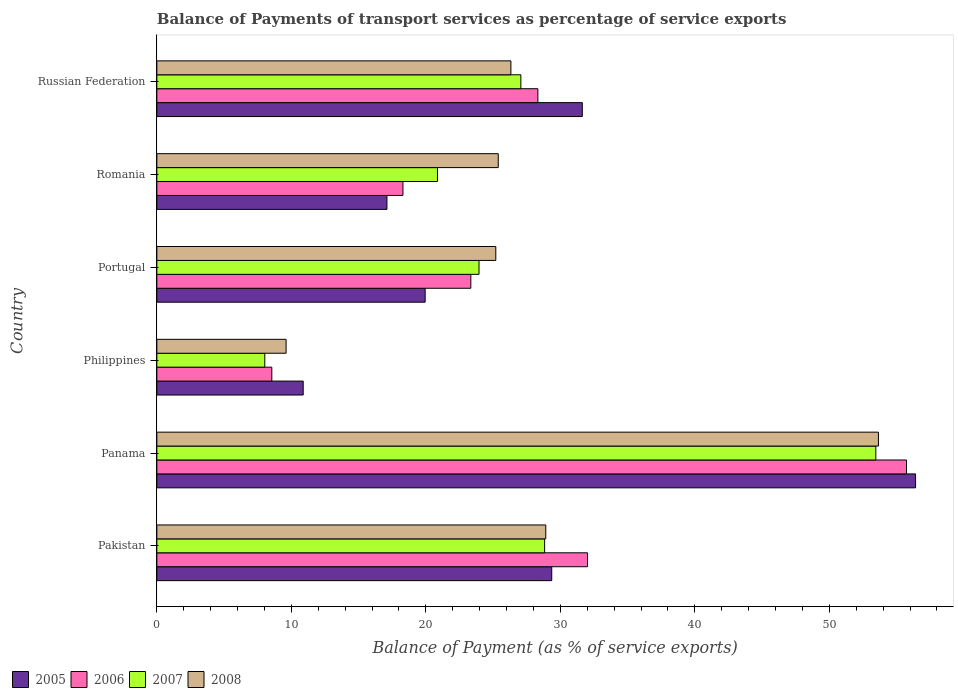How many different coloured bars are there?
Ensure brevity in your answer.  4. How many groups of bars are there?
Your answer should be very brief. 6. Are the number of bars per tick equal to the number of legend labels?
Provide a succinct answer. Yes. How many bars are there on the 4th tick from the bottom?
Your answer should be very brief. 4. What is the label of the 6th group of bars from the top?
Offer a terse response. Pakistan. What is the balance of payments of transport services in 2007 in Panama?
Your response must be concise. 53.45. Across all countries, what is the maximum balance of payments of transport services in 2007?
Give a very brief answer. 53.45. Across all countries, what is the minimum balance of payments of transport services in 2006?
Keep it short and to the point. 8.55. In which country was the balance of payments of transport services in 2008 maximum?
Ensure brevity in your answer.  Panama. In which country was the balance of payments of transport services in 2008 minimum?
Your answer should be very brief. Philippines. What is the total balance of payments of transport services in 2008 in the graph?
Offer a very short reply. 169.08. What is the difference between the balance of payments of transport services in 2008 in Philippines and that in Portugal?
Your answer should be very brief. -15.59. What is the difference between the balance of payments of transport services in 2006 in Russian Federation and the balance of payments of transport services in 2005 in Pakistan?
Give a very brief answer. -1.03. What is the average balance of payments of transport services in 2007 per country?
Offer a terse response. 27.03. What is the difference between the balance of payments of transport services in 2007 and balance of payments of transport services in 2008 in Russian Federation?
Provide a succinct answer. 0.74. In how many countries, is the balance of payments of transport services in 2006 greater than 30 %?
Make the answer very short. 2. What is the ratio of the balance of payments of transport services in 2008 in Panama to that in Philippines?
Ensure brevity in your answer.  5.58. Is the balance of payments of transport services in 2007 in Romania less than that in Russian Federation?
Your answer should be compact. Yes. Is the difference between the balance of payments of transport services in 2007 in Philippines and Portugal greater than the difference between the balance of payments of transport services in 2008 in Philippines and Portugal?
Offer a very short reply. No. What is the difference between the highest and the second highest balance of payments of transport services in 2007?
Provide a short and direct response. 24.62. What is the difference between the highest and the lowest balance of payments of transport services in 2005?
Your answer should be very brief. 45.53. What does the 1st bar from the bottom in Philippines represents?
Your answer should be compact. 2005. How many bars are there?
Your answer should be compact. 24. How many countries are there in the graph?
Keep it short and to the point. 6. Are the values on the major ticks of X-axis written in scientific E-notation?
Offer a very short reply. No. Does the graph contain any zero values?
Offer a very short reply. No. Does the graph contain grids?
Provide a succinct answer. No. Where does the legend appear in the graph?
Ensure brevity in your answer.  Bottom left. How many legend labels are there?
Provide a short and direct response. 4. What is the title of the graph?
Make the answer very short. Balance of Payments of transport services as percentage of service exports. What is the label or title of the X-axis?
Your answer should be very brief. Balance of Payment (as % of service exports). What is the Balance of Payment (as % of service exports) in 2005 in Pakistan?
Your answer should be compact. 29.36. What is the Balance of Payment (as % of service exports) of 2006 in Pakistan?
Make the answer very short. 32.02. What is the Balance of Payment (as % of service exports) of 2007 in Pakistan?
Your response must be concise. 28.83. What is the Balance of Payment (as % of service exports) in 2008 in Pakistan?
Offer a terse response. 28.91. What is the Balance of Payment (as % of service exports) in 2005 in Panama?
Your response must be concise. 56.41. What is the Balance of Payment (as % of service exports) in 2006 in Panama?
Your answer should be very brief. 55.73. What is the Balance of Payment (as % of service exports) in 2007 in Panama?
Your response must be concise. 53.45. What is the Balance of Payment (as % of service exports) of 2008 in Panama?
Your answer should be very brief. 53.65. What is the Balance of Payment (as % of service exports) of 2005 in Philippines?
Offer a very short reply. 10.88. What is the Balance of Payment (as % of service exports) of 2006 in Philippines?
Ensure brevity in your answer.  8.55. What is the Balance of Payment (as % of service exports) in 2007 in Philippines?
Ensure brevity in your answer.  8.02. What is the Balance of Payment (as % of service exports) of 2008 in Philippines?
Your response must be concise. 9.61. What is the Balance of Payment (as % of service exports) in 2005 in Portugal?
Keep it short and to the point. 19.95. What is the Balance of Payment (as % of service exports) of 2006 in Portugal?
Provide a succinct answer. 23.34. What is the Balance of Payment (as % of service exports) of 2007 in Portugal?
Provide a short and direct response. 23.95. What is the Balance of Payment (as % of service exports) of 2008 in Portugal?
Your answer should be very brief. 25.2. What is the Balance of Payment (as % of service exports) in 2005 in Romania?
Provide a short and direct response. 17.11. What is the Balance of Payment (as % of service exports) in 2006 in Romania?
Keep it short and to the point. 18.3. What is the Balance of Payment (as % of service exports) in 2007 in Romania?
Provide a succinct answer. 20.86. What is the Balance of Payment (as % of service exports) in 2008 in Romania?
Keep it short and to the point. 25.38. What is the Balance of Payment (as % of service exports) of 2005 in Russian Federation?
Your answer should be compact. 31.63. What is the Balance of Payment (as % of service exports) in 2006 in Russian Federation?
Your answer should be compact. 28.33. What is the Balance of Payment (as % of service exports) in 2007 in Russian Federation?
Provide a succinct answer. 27.06. What is the Balance of Payment (as % of service exports) of 2008 in Russian Federation?
Offer a very short reply. 26.32. Across all countries, what is the maximum Balance of Payment (as % of service exports) in 2005?
Offer a terse response. 56.41. Across all countries, what is the maximum Balance of Payment (as % of service exports) of 2006?
Keep it short and to the point. 55.73. Across all countries, what is the maximum Balance of Payment (as % of service exports) of 2007?
Offer a very short reply. 53.45. Across all countries, what is the maximum Balance of Payment (as % of service exports) of 2008?
Make the answer very short. 53.65. Across all countries, what is the minimum Balance of Payment (as % of service exports) in 2005?
Your answer should be compact. 10.88. Across all countries, what is the minimum Balance of Payment (as % of service exports) of 2006?
Provide a short and direct response. 8.55. Across all countries, what is the minimum Balance of Payment (as % of service exports) in 2007?
Your answer should be compact. 8.02. Across all countries, what is the minimum Balance of Payment (as % of service exports) in 2008?
Keep it short and to the point. 9.61. What is the total Balance of Payment (as % of service exports) of 2005 in the graph?
Offer a terse response. 165.33. What is the total Balance of Payment (as % of service exports) of 2006 in the graph?
Offer a terse response. 166.27. What is the total Balance of Payment (as % of service exports) in 2007 in the graph?
Your answer should be compact. 162.19. What is the total Balance of Payment (as % of service exports) in 2008 in the graph?
Your response must be concise. 169.08. What is the difference between the Balance of Payment (as % of service exports) in 2005 in Pakistan and that in Panama?
Keep it short and to the point. -27.05. What is the difference between the Balance of Payment (as % of service exports) in 2006 in Pakistan and that in Panama?
Your answer should be compact. -23.71. What is the difference between the Balance of Payment (as % of service exports) in 2007 in Pakistan and that in Panama?
Your response must be concise. -24.62. What is the difference between the Balance of Payment (as % of service exports) of 2008 in Pakistan and that in Panama?
Ensure brevity in your answer.  -24.73. What is the difference between the Balance of Payment (as % of service exports) in 2005 in Pakistan and that in Philippines?
Offer a terse response. 18.48. What is the difference between the Balance of Payment (as % of service exports) in 2006 in Pakistan and that in Philippines?
Give a very brief answer. 23.47. What is the difference between the Balance of Payment (as % of service exports) in 2007 in Pakistan and that in Philippines?
Give a very brief answer. 20.81. What is the difference between the Balance of Payment (as % of service exports) of 2008 in Pakistan and that in Philippines?
Provide a succinct answer. 19.31. What is the difference between the Balance of Payment (as % of service exports) in 2005 in Pakistan and that in Portugal?
Offer a terse response. 9.41. What is the difference between the Balance of Payment (as % of service exports) of 2006 in Pakistan and that in Portugal?
Keep it short and to the point. 8.68. What is the difference between the Balance of Payment (as % of service exports) of 2007 in Pakistan and that in Portugal?
Your answer should be compact. 4.88. What is the difference between the Balance of Payment (as % of service exports) of 2008 in Pakistan and that in Portugal?
Offer a very short reply. 3.71. What is the difference between the Balance of Payment (as % of service exports) in 2005 in Pakistan and that in Romania?
Ensure brevity in your answer.  12.25. What is the difference between the Balance of Payment (as % of service exports) in 2006 in Pakistan and that in Romania?
Give a very brief answer. 13.72. What is the difference between the Balance of Payment (as % of service exports) of 2007 in Pakistan and that in Romania?
Your answer should be compact. 7.97. What is the difference between the Balance of Payment (as % of service exports) in 2008 in Pakistan and that in Romania?
Your response must be concise. 3.53. What is the difference between the Balance of Payment (as % of service exports) of 2005 in Pakistan and that in Russian Federation?
Your answer should be very brief. -2.27. What is the difference between the Balance of Payment (as % of service exports) in 2006 in Pakistan and that in Russian Federation?
Give a very brief answer. 3.69. What is the difference between the Balance of Payment (as % of service exports) in 2007 in Pakistan and that in Russian Federation?
Make the answer very short. 1.77. What is the difference between the Balance of Payment (as % of service exports) of 2008 in Pakistan and that in Russian Federation?
Ensure brevity in your answer.  2.59. What is the difference between the Balance of Payment (as % of service exports) of 2005 in Panama and that in Philippines?
Your response must be concise. 45.53. What is the difference between the Balance of Payment (as % of service exports) of 2006 in Panama and that in Philippines?
Make the answer very short. 47.19. What is the difference between the Balance of Payment (as % of service exports) of 2007 in Panama and that in Philippines?
Make the answer very short. 45.43. What is the difference between the Balance of Payment (as % of service exports) in 2008 in Panama and that in Philippines?
Ensure brevity in your answer.  44.04. What is the difference between the Balance of Payment (as % of service exports) in 2005 in Panama and that in Portugal?
Your answer should be very brief. 36.46. What is the difference between the Balance of Payment (as % of service exports) in 2006 in Panama and that in Portugal?
Your response must be concise. 32.39. What is the difference between the Balance of Payment (as % of service exports) of 2007 in Panama and that in Portugal?
Your response must be concise. 29.5. What is the difference between the Balance of Payment (as % of service exports) in 2008 in Panama and that in Portugal?
Provide a short and direct response. 28.45. What is the difference between the Balance of Payment (as % of service exports) of 2005 in Panama and that in Romania?
Your answer should be compact. 39.3. What is the difference between the Balance of Payment (as % of service exports) in 2006 in Panama and that in Romania?
Ensure brevity in your answer.  37.44. What is the difference between the Balance of Payment (as % of service exports) of 2007 in Panama and that in Romania?
Give a very brief answer. 32.59. What is the difference between the Balance of Payment (as % of service exports) in 2008 in Panama and that in Romania?
Your answer should be compact. 28.26. What is the difference between the Balance of Payment (as % of service exports) in 2005 in Panama and that in Russian Federation?
Make the answer very short. 24.78. What is the difference between the Balance of Payment (as % of service exports) of 2006 in Panama and that in Russian Federation?
Make the answer very short. 27.4. What is the difference between the Balance of Payment (as % of service exports) in 2007 in Panama and that in Russian Federation?
Offer a terse response. 26.39. What is the difference between the Balance of Payment (as % of service exports) in 2008 in Panama and that in Russian Federation?
Make the answer very short. 27.32. What is the difference between the Balance of Payment (as % of service exports) of 2005 in Philippines and that in Portugal?
Make the answer very short. -9.07. What is the difference between the Balance of Payment (as % of service exports) of 2006 in Philippines and that in Portugal?
Offer a terse response. -14.8. What is the difference between the Balance of Payment (as % of service exports) of 2007 in Philippines and that in Portugal?
Offer a terse response. -15.93. What is the difference between the Balance of Payment (as % of service exports) of 2008 in Philippines and that in Portugal?
Provide a succinct answer. -15.59. What is the difference between the Balance of Payment (as % of service exports) in 2005 in Philippines and that in Romania?
Ensure brevity in your answer.  -6.23. What is the difference between the Balance of Payment (as % of service exports) in 2006 in Philippines and that in Romania?
Provide a succinct answer. -9.75. What is the difference between the Balance of Payment (as % of service exports) in 2007 in Philippines and that in Romania?
Keep it short and to the point. -12.84. What is the difference between the Balance of Payment (as % of service exports) in 2008 in Philippines and that in Romania?
Offer a terse response. -15.77. What is the difference between the Balance of Payment (as % of service exports) of 2005 in Philippines and that in Russian Federation?
Your answer should be very brief. -20.75. What is the difference between the Balance of Payment (as % of service exports) in 2006 in Philippines and that in Russian Federation?
Provide a short and direct response. -19.78. What is the difference between the Balance of Payment (as % of service exports) of 2007 in Philippines and that in Russian Federation?
Offer a very short reply. -19.04. What is the difference between the Balance of Payment (as % of service exports) in 2008 in Philippines and that in Russian Federation?
Make the answer very short. -16.71. What is the difference between the Balance of Payment (as % of service exports) of 2005 in Portugal and that in Romania?
Keep it short and to the point. 2.84. What is the difference between the Balance of Payment (as % of service exports) of 2006 in Portugal and that in Romania?
Make the answer very short. 5.05. What is the difference between the Balance of Payment (as % of service exports) of 2007 in Portugal and that in Romania?
Make the answer very short. 3.09. What is the difference between the Balance of Payment (as % of service exports) in 2008 in Portugal and that in Romania?
Offer a terse response. -0.18. What is the difference between the Balance of Payment (as % of service exports) of 2005 in Portugal and that in Russian Federation?
Offer a terse response. -11.68. What is the difference between the Balance of Payment (as % of service exports) in 2006 in Portugal and that in Russian Federation?
Provide a succinct answer. -4.98. What is the difference between the Balance of Payment (as % of service exports) of 2007 in Portugal and that in Russian Federation?
Your answer should be very brief. -3.11. What is the difference between the Balance of Payment (as % of service exports) in 2008 in Portugal and that in Russian Federation?
Give a very brief answer. -1.12. What is the difference between the Balance of Payment (as % of service exports) in 2005 in Romania and that in Russian Federation?
Offer a very short reply. -14.53. What is the difference between the Balance of Payment (as % of service exports) of 2006 in Romania and that in Russian Federation?
Offer a terse response. -10.03. What is the difference between the Balance of Payment (as % of service exports) in 2007 in Romania and that in Russian Federation?
Your answer should be very brief. -6.2. What is the difference between the Balance of Payment (as % of service exports) in 2008 in Romania and that in Russian Federation?
Provide a short and direct response. -0.94. What is the difference between the Balance of Payment (as % of service exports) of 2005 in Pakistan and the Balance of Payment (as % of service exports) of 2006 in Panama?
Ensure brevity in your answer.  -26.37. What is the difference between the Balance of Payment (as % of service exports) in 2005 in Pakistan and the Balance of Payment (as % of service exports) in 2007 in Panama?
Make the answer very short. -24.09. What is the difference between the Balance of Payment (as % of service exports) in 2005 in Pakistan and the Balance of Payment (as % of service exports) in 2008 in Panama?
Your answer should be very brief. -24.29. What is the difference between the Balance of Payment (as % of service exports) in 2006 in Pakistan and the Balance of Payment (as % of service exports) in 2007 in Panama?
Give a very brief answer. -21.43. What is the difference between the Balance of Payment (as % of service exports) of 2006 in Pakistan and the Balance of Payment (as % of service exports) of 2008 in Panama?
Provide a succinct answer. -21.63. What is the difference between the Balance of Payment (as % of service exports) of 2007 in Pakistan and the Balance of Payment (as % of service exports) of 2008 in Panama?
Your answer should be compact. -24.82. What is the difference between the Balance of Payment (as % of service exports) in 2005 in Pakistan and the Balance of Payment (as % of service exports) in 2006 in Philippines?
Make the answer very short. 20.81. What is the difference between the Balance of Payment (as % of service exports) of 2005 in Pakistan and the Balance of Payment (as % of service exports) of 2007 in Philippines?
Provide a succinct answer. 21.33. What is the difference between the Balance of Payment (as % of service exports) of 2005 in Pakistan and the Balance of Payment (as % of service exports) of 2008 in Philippines?
Your answer should be compact. 19.75. What is the difference between the Balance of Payment (as % of service exports) in 2006 in Pakistan and the Balance of Payment (as % of service exports) in 2007 in Philippines?
Offer a very short reply. 24. What is the difference between the Balance of Payment (as % of service exports) of 2006 in Pakistan and the Balance of Payment (as % of service exports) of 2008 in Philippines?
Make the answer very short. 22.41. What is the difference between the Balance of Payment (as % of service exports) in 2007 in Pakistan and the Balance of Payment (as % of service exports) in 2008 in Philippines?
Offer a terse response. 19.22. What is the difference between the Balance of Payment (as % of service exports) in 2005 in Pakistan and the Balance of Payment (as % of service exports) in 2006 in Portugal?
Offer a very short reply. 6.02. What is the difference between the Balance of Payment (as % of service exports) of 2005 in Pakistan and the Balance of Payment (as % of service exports) of 2007 in Portugal?
Offer a very short reply. 5.41. What is the difference between the Balance of Payment (as % of service exports) of 2005 in Pakistan and the Balance of Payment (as % of service exports) of 2008 in Portugal?
Offer a terse response. 4.16. What is the difference between the Balance of Payment (as % of service exports) in 2006 in Pakistan and the Balance of Payment (as % of service exports) in 2007 in Portugal?
Offer a terse response. 8.07. What is the difference between the Balance of Payment (as % of service exports) in 2006 in Pakistan and the Balance of Payment (as % of service exports) in 2008 in Portugal?
Offer a very short reply. 6.82. What is the difference between the Balance of Payment (as % of service exports) in 2007 in Pakistan and the Balance of Payment (as % of service exports) in 2008 in Portugal?
Give a very brief answer. 3.63. What is the difference between the Balance of Payment (as % of service exports) of 2005 in Pakistan and the Balance of Payment (as % of service exports) of 2006 in Romania?
Your answer should be very brief. 11.06. What is the difference between the Balance of Payment (as % of service exports) of 2005 in Pakistan and the Balance of Payment (as % of service exports) of 2007 in Romania?
Offer a very short reply. 8.5. What is the difference between the Balance of Payment (as % of service exports) of 2005 in Pakistan and the Balance of Payment (as % of service exports) of 2008 in Romania?
Offer a terse response. 3.98. What is the difference between the Balance of Payment (as % of service exports) of 2006 in Pakistan and the Balance of Payment (as % of service exports) of 2007 in Romania?
Offer a terse response. 11.16. What is the difference between the Balance of Payment (as % of service exports) in 2006 in Pakistan and the Balance of Payment (as % of service exports) in 2008 in Romania?
Provide a succinct answer. 6.64. What is the difference between the Balance of Payment (as % of service exports) in 2007 in Pakistan and the Balance of Payment (as % of service exports) in 2008 in Romania?
Keep it short and to the point. 3.45. What is the difference between the Balance of Payment (as % of service exports) of 2005 in Pakistan and the Balance of Payment (as % of service exports) of 2006 in Russian Federation?
Your response must be concise. 1.03. What is the difference between the Balance of Payment (as % of service exports) in 2005 in Pakistan and the Balance of Payment (as % of service exports) in 2007 in Russian Federation?
Offer a terse response. 2.3. What is the difference between the Balance of Payment (as % of service exports) of 2005 in Pakistan and the Balance of Payment (as % of service exports) of 2008 in Russian Federation?
Your response must be concise. 3.04. What is the difference between the Balance of Payment (as % of service exports) in 2006 in Pakistan and the Balance of Payment (as % of service exports) in 2007 in Russian Federation?
Your answer should be very brief. 4.96. What is the difference between the Balance of Payment (as % of service exports) of 2006 in Pakistan and the Balance of Payment (as % of service exports) of 2008 in Russian Federation?
Make the answer very short. 5.7. What is the difference between the Balance of Payment (as % of service exports) in 2007 in Pakistan and the Balance of Payment (as % of service exports) in 2008 in Russian Federation?
Offer a terse response. 2.51. What is the difference between the Balance of Payment (as % of service exports) in 2005 in Panama and the Balance of Payment (as % of service exports) in 2006 in Philippines?
Provide a short and direct response. 47.86. What is the difference between the Balance of Payment (as % of service exports) of 2005 in Panama and the Balance of Payment (as % of service exports) of 2007 in Philippines?
Provide a short and direct response. 48.38. What is the difference between the Balance of Payment (as % of service exports) of 2005 in Panama and the Balance of Payment (as % of service exports) of 2008 in Philippines?
Keep it short and to the point. 46.8. What is the difference between the Balance of Payment (as % of service exports) in 2006 in Panama and the Balance of Payment (as % of service exports) in 2007 in Philippines?
Give a very brief answer. 47.71. What is the difference between the Balance of Payment (as % of service exports) in 2006 in Panama and the Balance of Payment (as % of service exports) in 2008 in Philippines?
Offer a very short reply. 46.12. What is the difference between the Balance of Payment (as % of service exports) in 2007 in Panama and the Balance of Payment (as % of service exports) in 2008 in Philippines?
Your answer should be compact. 43.84. What is the difference between the Balance of Payment (as % of service exports) in 2005 in Panama and the Balance of Payment (as % of service exports) in 2006 in Portugal?
Your answer should be compact. 33.06. What is the difference between the Balance of Payment (as % of service exports) of 2005 in Panama and the Balance of Payment (as % of service exports) of 2007 in Portugal?
Offer a very short reply. 32.46. What is the difference between the Balance of Payment (as % of service exports) of 2005 in Panama and the Balance of Payment (as % of service exports) of 2008 in Portugal?
Offer a terse response. 31.21. What is the difference between the Balance of Payment (as % of service exports) of 2006 in Panama and the Balance of Payment (as % of service exports) of 2007 in Portugal?
Offer a terse response. 31.78. What is the difference between the Balance of Payment (as % of service exports) of 2006 in Panama and the Balance of Payment (as % of service exports) of 2008 in Portugal?
Provide a short and direct response. 30.53. What is the difference between the Balance of Payment (as % of service exports) of 2007 in Panama and the Balance of Payment (as % of service exports) of 2008 in Portugal?
Provide a short and direct response. 28.25. What is the difference between the Balance of Payment (as % of service exports) of 2005 in Panama and the Balance of Payment (as % of service exports) of 2006 in Romania?
Make the answer very short. 38.11. What is the difference between the Balance of Payment (as % of service exports) of 2005 in Panama and the Balance of Payment (as % of service exports) of 2007 in Romania?
Keep it short and to the point. 35.54. What is the difference between the Balance of Payment (as % of service exports) in 2005 in Panama and the Balance of Payment (as % of service exports) in 2008 in Romania?
Keep it short and to the point. 31.02. What is the difference between the Balance of Payment (as % of service exports) in 2006 in Panama and the Balance of Payment (as % of service exports) in 2007 in Romania?
Your response must be concise. 34.87. What is the difference between the Balance of Payment (as % of service exports) in 2006 in Panama and the Balance of Payment (as % of service exports) in 2008 in Romania?
Ensure brevity in your answer.  30.35. What is the difference between the Balance of Payment (as % of service exports) of 2007 in Panama and the Balance of Payment (as % of service exports) of 2008 in Romania?
Offer a terse response. 28.07. What is the difference between the Balance of Payment (as % of service exports) of 2005 in Panama and the Balance of Payment (as % of service exports) of 2006 in Russian Federation?
Ensure brevity in your answer.  28.08. What is the difference between the Balance of Payment (as % of service exports) of 2005 in Panama and the Balance of Payment (as % of service exports) of 2007 in Russian Federation?
Offer a very short reply. 29.34. What is the difference between the Balance of Payment (as % of service exports) of 2005 in Panama and the Balance of Payment (as % of service exports) of 2008 in Russian Federation?
Provide a succinct answer. 30.09. What is the difference between the Balance of Payment (as % of service exports) of 2006 in Panama and the Balance of Payment (as % of service exports) of 2007 in Russian Federation?
Your response must be concise. 28.67. What is the difference between the Balance of Payment (as % of service exports) of 2006 in Panama and the Balance of Payment (as % of service exports) of 2008 in Russian Federation?
Provide a succinct answer. 29.41. What is the difference between the Balance of Payment (as % of service exports) in 2007 in Panama and the Balance of Payment (as % of service exports) in 2008 in Russian Federation?
Offer a terse response. 27.13. What is the difference between the Balance of Payment (as % of service exports) of 2005 in Philippines and the Balance of Payment (as % of service exports) of 2006 in Portugal?
Keep it short and to the point. -12.46. What is the difference between the Balance of Payment (as % of service exports) in 2005 in Philippines and the Balance of Payment (as % of service exports) in 2007 in Portugal?
Ensure brevity in your answer.  -13.07. What is the difference between the Balance of Payment (as % of service exports) of 2005 in Philippines and the Balance of Payment (as % of service exports) of 2008 in Portugal?
Keep it short and to the point. -14.32. What is the difference between the Balance of Payment (as % of service exports) of 2006 in Philippines and the Balance of Payment (as % of service exports) of 2007 in Portugal?
Ensure brevity in your answer.  -15.4. What is the difference between the Balance of Payment (as % of service exports) in 2006 in Philippines and the Balance of Payment (as % of service exports) in 2008 in Portugal?
Offer a terse response. -16.65. What is the difference between the Balance of Payment (as % of service exports) of 2007 in Philippines and the Balance of Payment (as % of service exports) of 2008 in Portugal?
Keep it short and to the point. -17.18. What is the difference between the Balance of Payment (as % of service exports) of 2005 in Philippines and the Balance of Payment (as % of service exports) of 2006 in Romania?
Make the answer very short. -7.42. What is the difference between the Balance of Payment (as % of service exports) in 2005 in Philippines and the Balance of Payment (as % of service exports) in 2007 in Romania?
Your answer should be very brief. -9.98. What is the difference between the Balance of Payment (as % of service exports) in 2005 in Philippines and the Balance of Payment (as % of service exports) in 2008 in Romania?
Make the answer very short. -14.5. What is the difference between the Balance of Payment (as % of service exports) of 2006 in Philippines and the Balance of Payment (as % of service exports) of 2007 in Romania?
Your response must be concise. -12.32. What is the difference between the Balance of Payment (as % of service exports) in 2006 in Philippines and the Balance of Payment (as % of service exports) in 2008 in Romania?
Your response must be concise. -16.84. What is the difference between the Balance of Payment (as % of service exports) in 2007 in Philippines and the Balance of Payment (as % of service exports) in 2008 in Romania?
Offer a terse response. -17.36. What is the difference between the Balance of Payment (as % of service exports) in 2005 in Philippines and the Balance of Payment (as % of service exports) in 2006 in Russian Federation?
Offer a very short reply. -17.45. What is the difference between the Balance of Payment (as % of service exports) in 2005 in Philippines and the Balance of Payment (as % of service exports) in 2007 in Russian Federation?
Offer a terse response. -16.18. What is the difference between the Balance of Payment (as % of service exports) of 2005 in Philippines and the Balance of Payment (as % of service exports) of 2008 in Russian Federation?
Your response must be concise. -15.44. What is the difference between the Balance of Payment (as % of service exports) of 2006 in Philippines and the Balance of Payment (as % of service exports) of 2007 in Russian Federation?
Give a very brief answer. -18.51. What is the difference between the Balance of Payment (as % of service exports) of 2006 in Philippines and the Balance of Payment (as % of service exports) of 2008 in Russian Federation?
Your response must be concise. -17.77. What is the difference between the Balance of Payment (as % of service exports) of 2007 in Philippines and the Balance of Payment (as % of service exports) of 2008 in Russian Federation?
Provide a short and direct response. -18.3. What is the difference between the Balance of Payment (as % of service exports) of 2005 in Portugal and the Balance of Payment (as % of service exports) of 2006 in Romania?
Offer a terse response. 1.65. What is the difference between the Balance of Payment (as % of service exports) of 2005 in Portugal and the Balance of Payment (as % of service exports) of 2007 in Romania?
Provide a succinct answer. -0.91. What is the difference between the Balance of Payment (as % of service exports) of 2005 in Portugal and the Balance of Payment (as % of service exports) of 2008 in Romania?
Offer a very short reply. -5.43. What is the difference between the Balance of Payment (as % of service exports) of 2006 in Portugal and the Balance of Payment (as % of service exports) of 2007 in Romania?
Provide a short and direct response. 2.48. What is the difference between the Balance of Payment (as % of service exports) in 2006 in Portugal and the Balance of Payment (as % of service exports) in 2008 in Romania?
Your answer should be compact. -2.04. What is the difference between the Balance of Payment (as % of service exports) in 2007 in Portugal and the Balance of Payment (as % of service exports) in 2008 in Romania?
Ensure brevity in your answer.  -1.43. What is the difference between the Balance of Payment (as % of service exports) of 2005 in Portugal and the Balance of Payment (as % of service exports) of 2006 in Russian Federation?
Offer a terse response. -8.38. What is the difference between the Balance of Payment (as % of service exports) of 2005 in Portugal and the Balance of Payment (as % of service exports) of 2007 in Russian Federation?
Provide a succinct answer. -7.11. What is the difference between the Balance of Payment (as % of service exports) in 2005 in Portugal and the Balance of Payment (as % of service exports) in 2008 in Russian Federation?
Your answer should be compact. -6.37. What is the difference between the Balance of Payment (as % of service exports) of 2006 in Portugal and the Balance of Payment (as % of service exports) of 2007 in Russian Federation?
Keep it short and to the point. -3.72. What is the difference between the Balance of Payment (as % of service exports) in 2006 in Portugal and the Balance of Payment (as % of service exports) in 2008 in Russian Federation?
Give a very brief answer. -2.98. What is the difference between the Balance of Payment (as % of service exports) of 2007 in Portugal and the Balance of Payment (as % of service exports) of 2008 in Russian Federation?
Make the answer very short. -2.37. What is the difference between the Balance of Payment (as % of service exports) in 2005 in Romania and the Balance of Payment (as % of service exports) in 2006 in Russian Federation?
Your response must be concise. -11.22. What is the difference between the Balance of Payment (as % of service exports) in 2005 in Romania and the Balance of Payment (as % of service exports) in 2007 in Russian Federation?
Ensure brevity in your answer.  -9.96. What is the difference between the Balance of Payment (as % of service exports) in 2005 in Romania and the Balance of Payment (as % of service exports) in 2008 in Russian Federation?
Your response must be concise. -9.22. What is the difference between the Balance of Payment (as % of service exports) in 2006 in Romania and the Balance of Payment (as % of service exports) in 2007 in Russian Federation?
Keep it short and to the point. -8.77. What is the difference between the Balance of Payment (as % of service exports) in 2006 in Romania and the Balance of Payment (as % of service exports) in 2008 in Russian Federation?
Your answer should be very brief. -8.03. What is the difference between the Balance of Payment (as % of service exports) of 2007 in Romania and the Balance of Payment (as % of service exports) of 2008 in Russian Federation?
Provide a short and direct response. -5.46. What is the average Balance of Payment (as % of service exports) of 2005 per country?
Provide a succinct answer. 27.56. What is the average Balance of Payment (as % of service exports) of 2006 per country?
Offer a terse response. 27.71. What is the average Balance of Payment (as % of service exports) of 2007 per country?
Ensure brevity in your answer.  27.03. What is the average Balance of Payment (as % of service exports) in 2008 per country?
Give a very brief answer. 28.18. What is the difference between the Balance of Payment (as % of service exports) in 2005 and Balance of Payment (as % of service exports) in 2006 in Pakistan?
Offer a very short reply. -2.66. What is the difference between the Balance of Payment (as % of service exports) in 2005 and Balance of Payment (as % of service exports) in 2007 in Pakistan?
Provide a succinct answer. 0.53. What is the difference between the Balance of Payment (as % of service exports) of 2005 and Balance of Payment (as % of service exports) of 2008 in Pakistan?
Ensure brevity in your answer.  0.44. What is the difference between the Balance of Payment (as % of service exports) of 2006 and Balance of Payment (as % of service exports) of 2007 in Pakistan?
Keep it short and to the point. 3.19. What is the difference between the Balance of Payment (as % of service exports) in 2006 and Balance of Payment (as % of service exports) in 2008 in Pakistan?
Provide a succinct answer. 3.1. What is the difference between the Balance of Payment (as % of service exports) in 2007 and Balance of Payment (as % of service exports) in 2008 in Pakistan?
Give a very brief answer. -0.08. What is the difference between the Balance of Payment (as % of service exports) in 2005 and Balance of Payment (as % of service exports) in 2006 in Panama?
Provide a succinct answer. 0.67. What is the difference between the Balance of Payment (as % of service exports) of 2005 and Balance of Payment (as % of service exports) of 2007 in Panama?
Give a very brief answer. 2.95. What is the difference between the Balance of Payment (as % of service exports) in 2005 and Balance of Payment (as % of service exports) in 2008 in Panama?
Ensure brevity in your answer.  2.76. What is the difference between the Balance of Payment (as % of service exports) of 2006 and Balance of Payment (as % of service exports) of 2007 in Panama?
Offer a terse response. 2.28. What is the difference between the Balance of Payment (as % of service exports) in 2006 and Balance of Payment (as % of service exports) in 2008 in Panama?
Your response must be concise. 2.09. What is the difference between the Balance of Payment (as % of service exports) in 2007 and Balance of Payment (as % of service exports) in 2008 in Panama?
Provide a succinct answer. -0.19. What is the difference between the Balance of Payment (as % of service exports) in 2005 and Balance of Payment (as % of service exports) in 2006 in Philippines?
Your answer should be compact. 2.33. What is the difference between the Balance of Payment (as % of service exports) of 2005 and Balance of Payment (as % of service exports) of 2007 in Philippines?
Give a very brief answer. 2.86. What is the difference between the Balance of Payment (as % of service exports) of 2005 and Balance of Payment (as % of service exports) of 2008 in Philippines?
Offer a terse response. 1.27. What is the difference between the Balance of Payment (as % of service exports) of 2006 and Balance of Payment (as % of service exports) of 2007 in Philippines?
Your answer should be very brief. 0.52. What is the difference between the Balance of Payment (as % of service exports) of 2006 and Balance of Payment (as % of service exports) of 2008 in Philippines?
Provide a succinct answer. -1.06. What is the difference between the Balance of Payment (as % of service exports) of 2007 and Balance of Payment (as % of service exports) of 2008 in Philippines?
Provide a short and direct response. -1.58. What is the difference between the Balance of Payment (as % of service exports) in 2005 and Balance of Payment (as % of service exports) in 2006 in Portugal?
Your answer should be very brief. -3.4. What is the difference between the Balance of Payment (as % of service exports) in 2005 and Balance of Payment (as % of service exports) in 2007 in Portugal?
Your answer should be very brief. -4. What is the difference between the Balance of Payment (as % of service exports) of 2005 and Balance of Payment (as % of service exports) of 2008 in Portugal?
Make the answer very short. -5.25. What is the difference between the Balance of Payment (as % of service exports) of 2006 and Balance of Payment (as % of service exports) of 2007 in Portugal?
Offer a very short reply. -0.61. What is the difference between the Balance of Payment (as % of service exports) in 2006 and Balance of Payment (as % of service exports) in 2008 in Portugal?
Provide a short and direct response. -1.86. What is the difference between the Balance of Payment (as % of service exports) in 2007 and Balance of Payment (as % of service exports) in 2008 in Portugal?
Provide a succinct answer. -1.25. What is the difference between the Balance of Payment (as % of service exports) of 2005 and Balance of Payment (as % of service exports) of 2006 in Romania?
Your answer should be compact. -1.19. What is the difference between the Balance of Payment (as % of service exports) of 2005 and Balance of Payment (as % of service exports) of 2007 in Romania?
Keep it short and to the point. -3.76. What is the difference between the Balance of Payment (as % of service exports) in 2005 and Balance of Payment (as % of service exports) in 2008 in Romania?
Your answer should be compact. -8.28. What is the difference between the Balance of Payment (as % of service exports) in 2006 and Balance of Payment (as % of service exports) in 2007 in Romania?
Provide a short and direct response. -2.57. What is the difference between the Balance of Payment (as % of service exports) of 2006 and Balance of Payment (as % of service exports) of 2008 in Romania?
Offer a very short reply. -7.09. What is the difference between the Balance of Payment (as % of service exports) in 2007 and Balance of Payment (as % of service exports) in 2008 in Romania?
Your response must be concise. -4.52. What is the difference between the Balance of Payment (as % of service exports) in 2005 and Balance of Payment (as % of service exports) in 2006 in Russian Federation?
Your answer should be compact. 3.3. What is the difference between the Balance of Payment (as % of service exports) in 2005 and Balance of Payment (as % of service exports) in 2007 in Russian Federation?
Your answer should be very brief. 4.57. What is the difference between the Balance of Payment (as % of service exports) in 2005 and Balance of Payment (as % of service exports) in 2008 in Russian Federation?
Ensure brevity in your answer.  5.31. What is the difference between the Balance of Payment (as % of service exports) in 2006 and Balance of Payment (as % of service exports) in 2007 in Russian Federation?
Provide a short and direct response. 1.27. What is the difference between the Balance of Payment (as % of service exports) in 2006 and Balance of Payment (as % of service exports) in 2008 in Russian Federation?
Keep it short and to the point. 2.01. What is the difference between the Balance of Payment (as % of service exports) in 2007 and Balance of Payment (as % of service exports) in 2008 in Russian Federation?
Offer a very short reply. 0.74. What is the ratio of the Balance of Payment (as % of service exports) in 2005 in Pakistan to that in Panama?
Provide a succinct answer. 0.52. What is the ratio of the Balance of Payment (as % of service exports) in 2006 in Pakistan to that in Panama?
Provide a short and direct response. 0.57. What is the ratio of the Balance of Payment (as % of service exports) in 2007 in Pakistan to that in Panama?
Offer a terse response. 0.54. What is the ratio of the Balance of Payment (as % of service exports) in 2008 in Pakistan to that in Panama?
Give a very brief answer. 0.54. What is the ratio of the Balance of Payment (as % of service exports) of 2005 in Pakistan to that in Philippines?
Your response must be concise. 2.7. What is the ratio of the Balance of Payment (as % of service exports) of 2006 in Pakistan to that in Philippines?
Ensure brevity in your answer.  3.75. What is the ratio of the Balance of Payment (as % of service exports) in 2007 in Pakistan to that in Philippines?
Your answer should be very brief. 3.59. What is the ratio of the Balance of Payment (as % of service exports) of 2008 in Pakistan to that in Philippines?
Provide a short and direct response. 3.01. What is the ratio of the Balance of Payment (as % of service exports) in 2005 in Pakistan to that in Portugal?
Offer a very short reply. 1.47. What is the ratio of the Balance of Payment (as % of service exports) of 2006 in Pakistan to that in Portugal?
Ensure brevity in your answer.  1.37. What is the ratio of the Balance of Payment (as % of service exports) in 2007 in Pakistan to that in Portugal?
Your answer should be very brief. 1.2. What is the ratio of the Balance of Payment (as % of service exports) in 2008 in Pakistan to that in Portugal?
Offer a terse response. 1.15. What is the ratio of the Balance of Payment (as % of service exports) in 2005 in Pakistan to that in Romania?
Your answer should be very brief. 1.72. What is the ratio of the Balance of Payment (as % of service exports) of 2006 in Pakistan to that in Romania?
Your answer should be very brief. 1.75. What is the ratio of the Balance of Payment (as % of service exports) in 2007 in Pakistan to that in Romania?
Make the answer very short. 1.38. What is the ratio of the Balance of Payment (as % of service exports) in 2008 in Pakistan to that in Romania?
Make the answer very short. 1.14. What is the ratio of the Balance of Payment (as % of service exports) in 2005 in Pakistan to that in Russian Federation?
Offer a very short reply. 0.93. What is the ratio of the Balance of Payment (as % of service exports) in 2006 in Pakistan to that in Russian Federation?
Your answer should be very brief. 1.13. What is the ratio of the Balance of Payment (as % of service exports) of 2007 in Pakistan to that in Russian Federation?
Provide a succinct answer. 1.07. What is the ratio of the Balance of Payment (as % of service exports) in 2008 in Pakistan to that in Russian Federation?
Provide a succinct answer. 1.1. What is the ratio of the Balance of Payment (as % of service exports) in 2005 in Panama to that in Philippines?
Offer a very short reply. 5.18. What is the ratio of the Balance of Payment (as % of service exports) of 2006 in Panama to that in Philippines?
Keep it short and to the point. 6.52. What is the ratio of the Balance of Payment (as % of service exports) in 2007 in Panama to that in Philippines?
Ensure brevity in your answer.  6.66. What is the ratio of the Balance of Payment (as % of service exports) in 2008 in Panama to that in Philippines?
Provide a succinct answer. 5.58. What is the ratio of the Balance of Payment (as % of service exports) in 2005 in Panama to that in Portugal?
Your answer should be very brief. 2.83. What is the ratio of the Balance of Payment (as % of service exports) in 2006 in Panama to that in Portugal?
Offer a very short reply. 2.39. What is the ratio of the Balance of Payment (as % of service exports) of 2007 in Panama to that in Portugal?
Keep it short and to the point. 2.23. What is the ratio of the Balance of Payment (as % of service exports) of 2008 in Panama to that in Portugal?
Your answer should be compact. 2.13. What is the ratio of the Balance of Payment (as % of service exports) of 2005 in Panama to that in Romania?
Offer a very short reply. 3.3. What is the ratio of the Balance of Payment (as % of service exports) of 2006 in Panama to that in Romania?
Provide a succinct answer. 3.05. What is the ratio of the Balance of Payment (as % of service exports) of 2007 in Panama to that in Romania?
Offer a very short reply. 2.56. What is the ratio of the Balance of Payment (as % of service exports) in 2008 in Panama to that in Romania?
Ensure brevity in your answer.  2.11. What is the ratio of the Balance of Payment (as % of service exports) in 2005 in Panama to that in Russian Federation?
Make the answer very short. 1.78. What is the ratio of the Balance of Payment (as % of service exports) in 2006 in Panama to that in Russian Federation?
Provide a short and direct response. 1.97. What is the ratio of the Balance of Payment (as % of service exports) of 2007 in Panama to that in Russian Federation?
Give a very brief answer. 1.98. What is the ratio of the Balance of Payment (as % of service exports) in 2008 in Panama to that in Russian Federation?
Keep it short and to the point. 2.04. What is the ratio of the Balance of Payment (as % of service exports) of 2005 in Philippines to that in Portugal?
Offer a terse response. 0.55. What is the ratio of the Balance of Payment (as % of service exports) in 2006 in Philippines to that in Portugal?
Make the answer very short. 0.37. What is the ratio of the Balance of Payment (as % of service exports) in 2007 in Philippines to that in Portugal?
Your answer should be compact. 0.34. What is the ratio of the Balance of Payment (as % of service exports) of 2008 in Philippines to that in Portugal?
Your response must be concise. 0.38. What is the ratio of the Balance of Payment (as % of service exports) of 2005 in Philippines to that in Romania?
Provide a succinct answer. 0.64. What is the ratio of the Balance of Payment (as % of service exports) in 2006 in Philippines to that in Romania?
Provide a short and direct response. 0.47. What is the ratio of the Balance of Payment (as % of service exports) in 2007 in Philippines to that in Romania?
Provide a succinct answer. 0.38. What is the ratio of the Balance of Payment (as % of service exports) of 2008 in Philippines to that in Romania?
Provide a short and direct response. 0.38. What is the ratio of the Balance of Payment (as % of service exports) in 2005 in Philippines to that in Russian Federation?
Your answer should be compact. 0.34. What is the ratio of the Balance of Payment (as % of service exports) in 2006 in Philippines to that in Russian Federation?
Make the answer very short. 0.3. What is the ratio of the Balance of Payment (as % of service exports) in 2007 in Philippines to that in Russian Federation?
Offer a very short reply. 0.3. What is the ratio of the Balance of Payment (as % of service exports) of 2008 in Philippines to that in Russian Federation?
Offer a terse response. 0.37. What is the ratio of the Balance of Payment (as % of service exports) in 2005 in Portugal to that in Romania?
Make the answer very short. 1.17. What is the ratio of the Balance of Payment (as % of service exports) of 2006 in Portugal to that in Romania?
Provide a short and direct response. 1.28. What is the ratio of the Balance of Payment (as % of service exports) of 2007 in Portugal to that in Romania?
Keep it short and to the point. 1.15. What is the ratio of the Balance of Payment (as % of service exports) of 2008 in Portugal to that in Romania?
Ensure brevity in your answer.  0.99. What is the ratio of the Balance of Payment (as % of service exports) in 2005 in Portugal to that in Russian Federation?
Keep it short and to the point. 0.63. What is the ratio of the Balance of Payment (as % of service exports) of 2006 in Portugal to that in Russian Federation?
Make the answer very short. 0.82. What is the ratio of the Balance of Payment (as % of service exports) in 2007 in Portugal to that in Russian Federation?
Make the answer very short. 0.89. What is the ratio of the Balance of Payment (as % of service exports) of 2008 in Portugal to that in Russian Federation?
Your response must be concise. 0.96. What is the ratio of the Balance of Payment (as % of service exports) in 2005 in Romania to that in Russian Federation?
Provide a short and direct response. 0.54. What is the ratio of the Balance of Payment (as % of service exports) in 2006 in Romania to that in Russian Federation?
Provide a succinct answer. 0.65. What is the ratio of the Balance of Payment (as % of service exports) in 2007 in Romania to that in Russian Federation?
Make the answer very short. 0.77. What is the difference between the highest and the second highest Balance of Payment (as % of service exports) of 2005?
Your answer should be compact. 24.78. What is the difference between the highest and the second highest Balance of Payment (as % of service exports) in 2006?
Keep it short and to the point. 23.71. What is the difference between the highest and the second highest Balance of Payment (as % of service exports) in 2007?
Provide a succinct answer. 24.62. What is the difference between the highest and the second highest Balance of Payment (as % of service exports) in 2008?
Offer a very short reply. 24.73. What is the difference between the highest and the lowest Balance of Payment (as % of service exports) in 2005?
Your response must be concise. 45.53. What is the difference between the highest and the lowest Balance of Payment (as % of service exports) of 2006?
Your response must be concise. 47.19. What is the difference between the highest and the lowest Balance of Payment (as % of service exports) in 2007?
Ensure brevity in your answer.  45.43. What is the difference between the highest and the lowest Balance of Payment (as % of service exports) in 2008?
Make the answer very short. 44.04. 